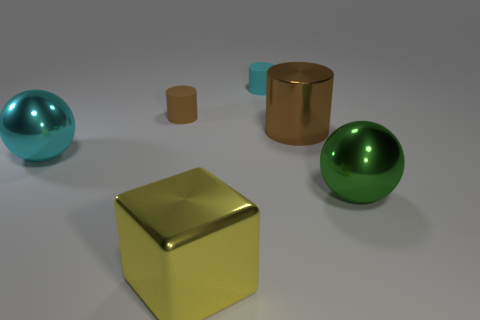Add 3 tiny purple rubber spheres. How many objects exist? 9 Subtract all spheres. How many objects are left? 4 Subtract 0 blue spheres. How many objects are left? 6 Subtract all tiny gray metal cylinders. Subtract all large brown things. How many objects are left? 5 Add 3 shiny balls. How many shiny balls are left? 5 Add 1 brown shiny things. How many brown shiny things exist? 2 